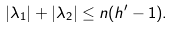Convert formula to latex. <formula><loc_0><loc_0><loc_500><loc_500>| \lambda _ { 1 } | + | \lambda _ { 2 } | \leq n ( h ^ { \prime } - 1 ) .</formula> 